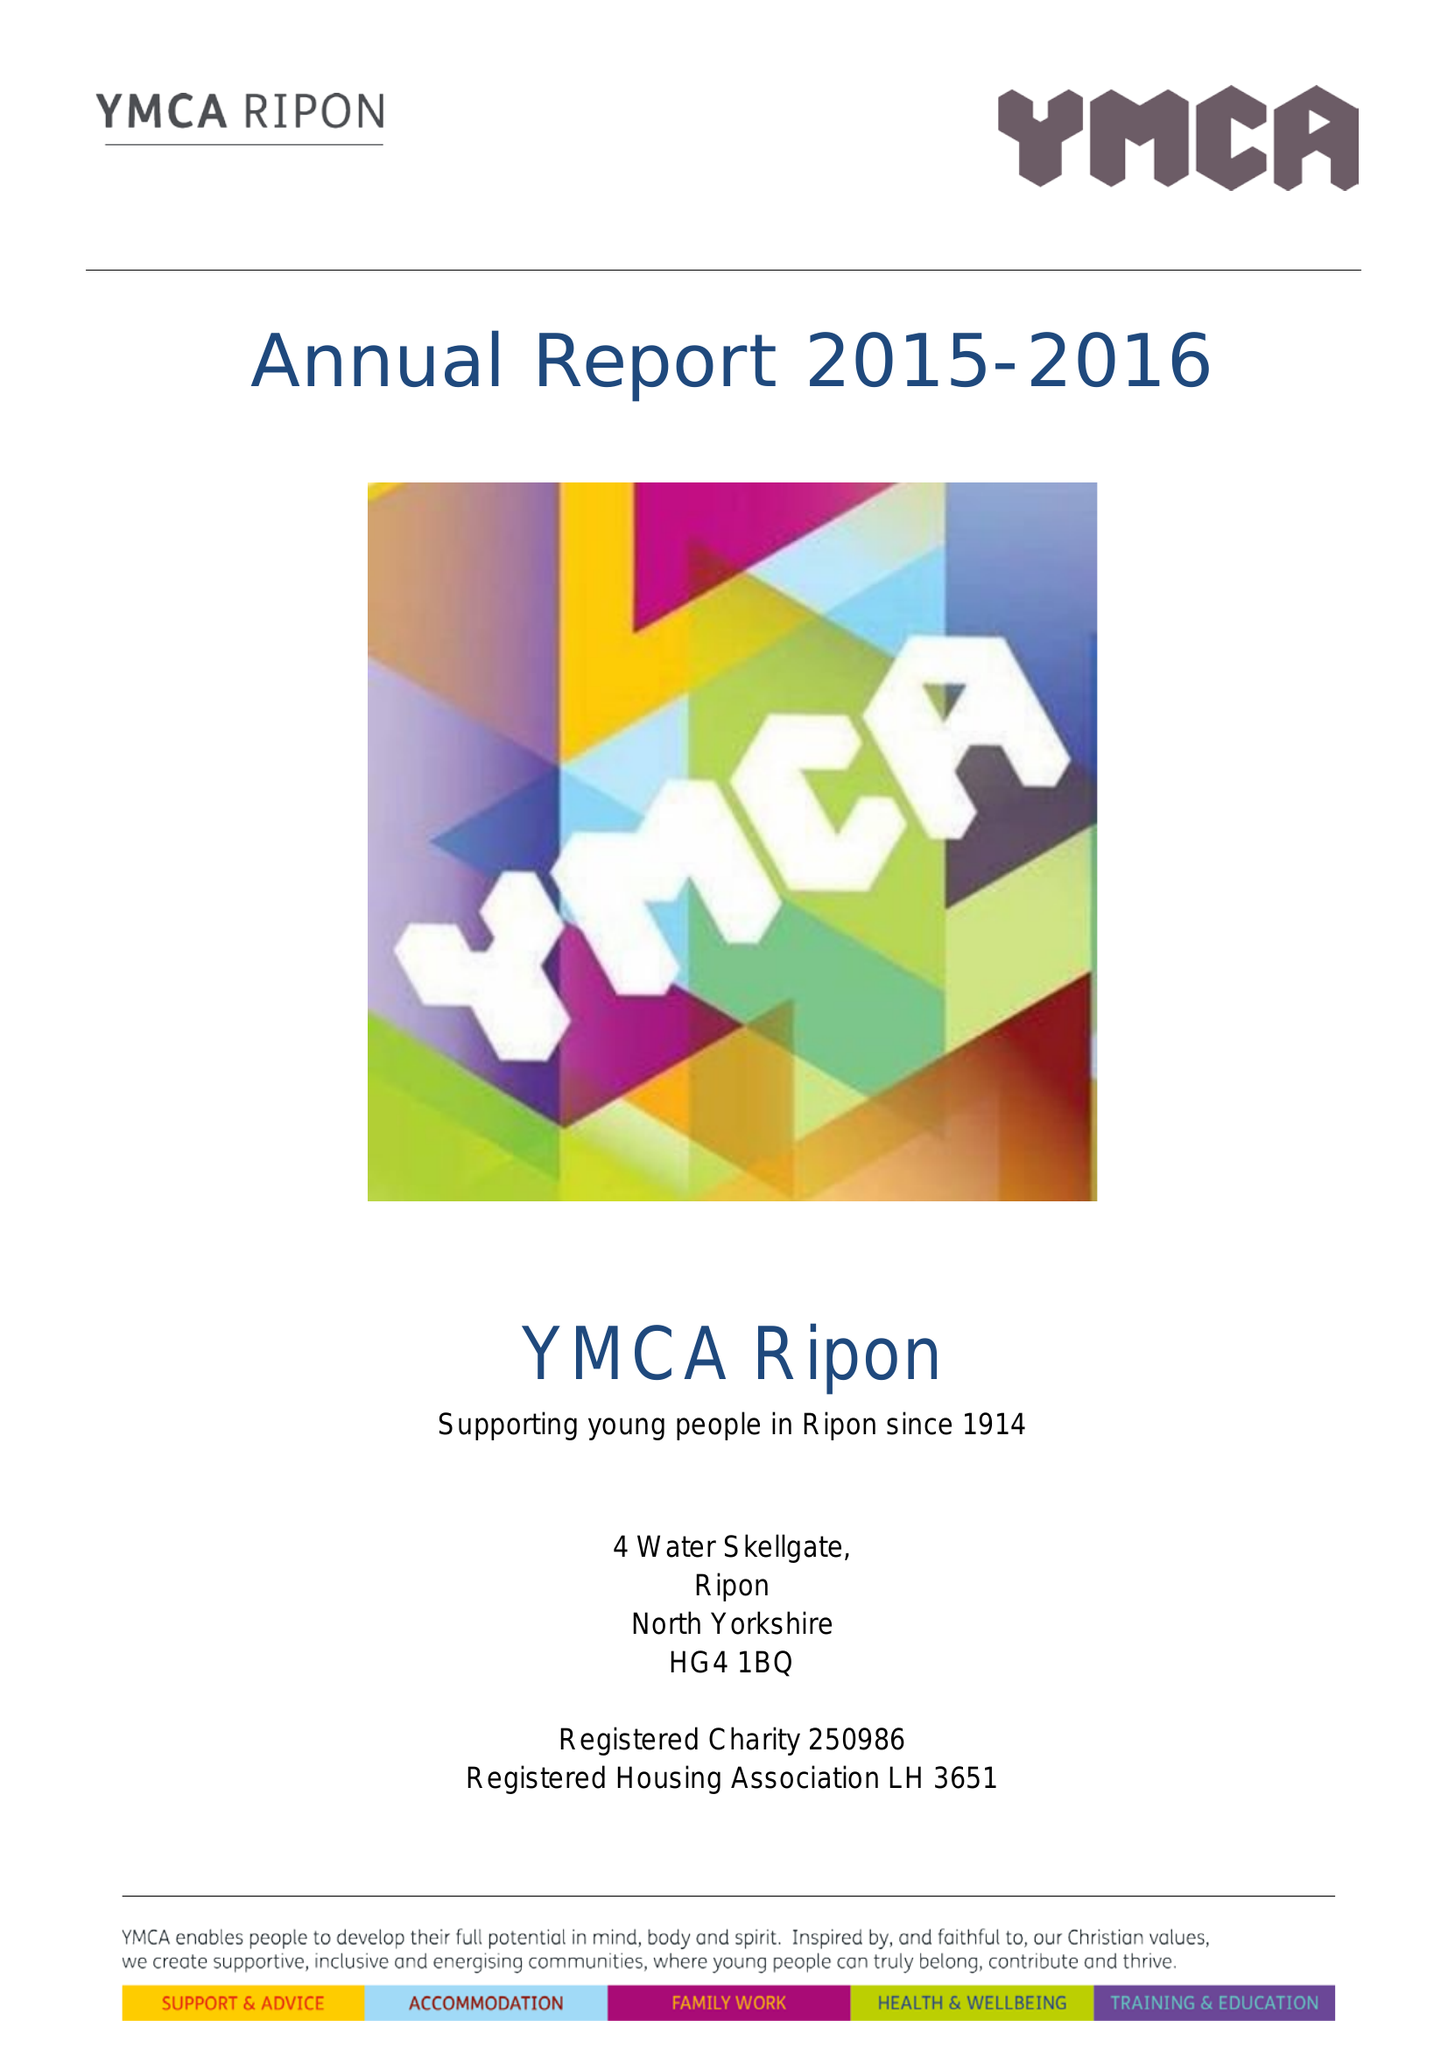What is the value for the charity_number?
Answer the question using a single word or phrase. 250986 